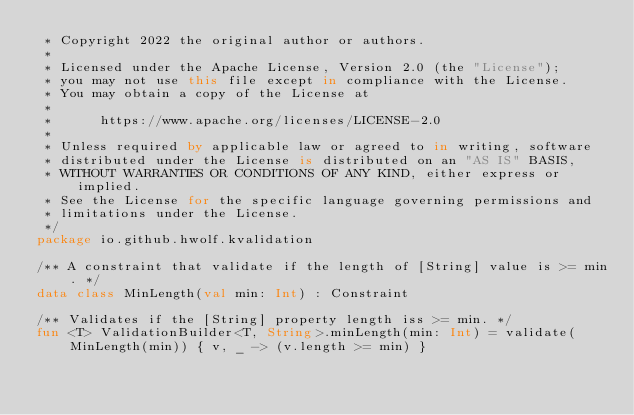<code> <loc_0><loc_0><loc_500><loc_500><_Kotlin_> * Copyright 2022 the original author or authors.
 *
 * Licensed under the Apache License, Version 2.0 (the "License");
 * you may not use this file except in compliance with the License.
 * You may obtain a copy of the License at
 *
 *      https://www.apache.org/licenses/LICENSE-2.0
 *
 * Unless required by applicable law or agreed to in writing, software
 * distributed under the License is distributed on an "AS IS" BASIS,
 * WITHOUT WARRANTIES OR CONDITIONS OF ANY KIND, either express or implied.
 * See the License for the specific language governing permissions and
 * limitations under the License.
 */
package io.github.hwolf.kvalidation

/** A constraint that validate if the length of [String] value is >= min. */
data class MinLength(val min: Int) : Constraint

/** Validates if the [String] property length iss >= min. */
fun <T> ValidationBuilder<T, String>.minLength(min: Int) = validate(MinLength(min)) { v, _ -> (v.length >= min) }
</code> 